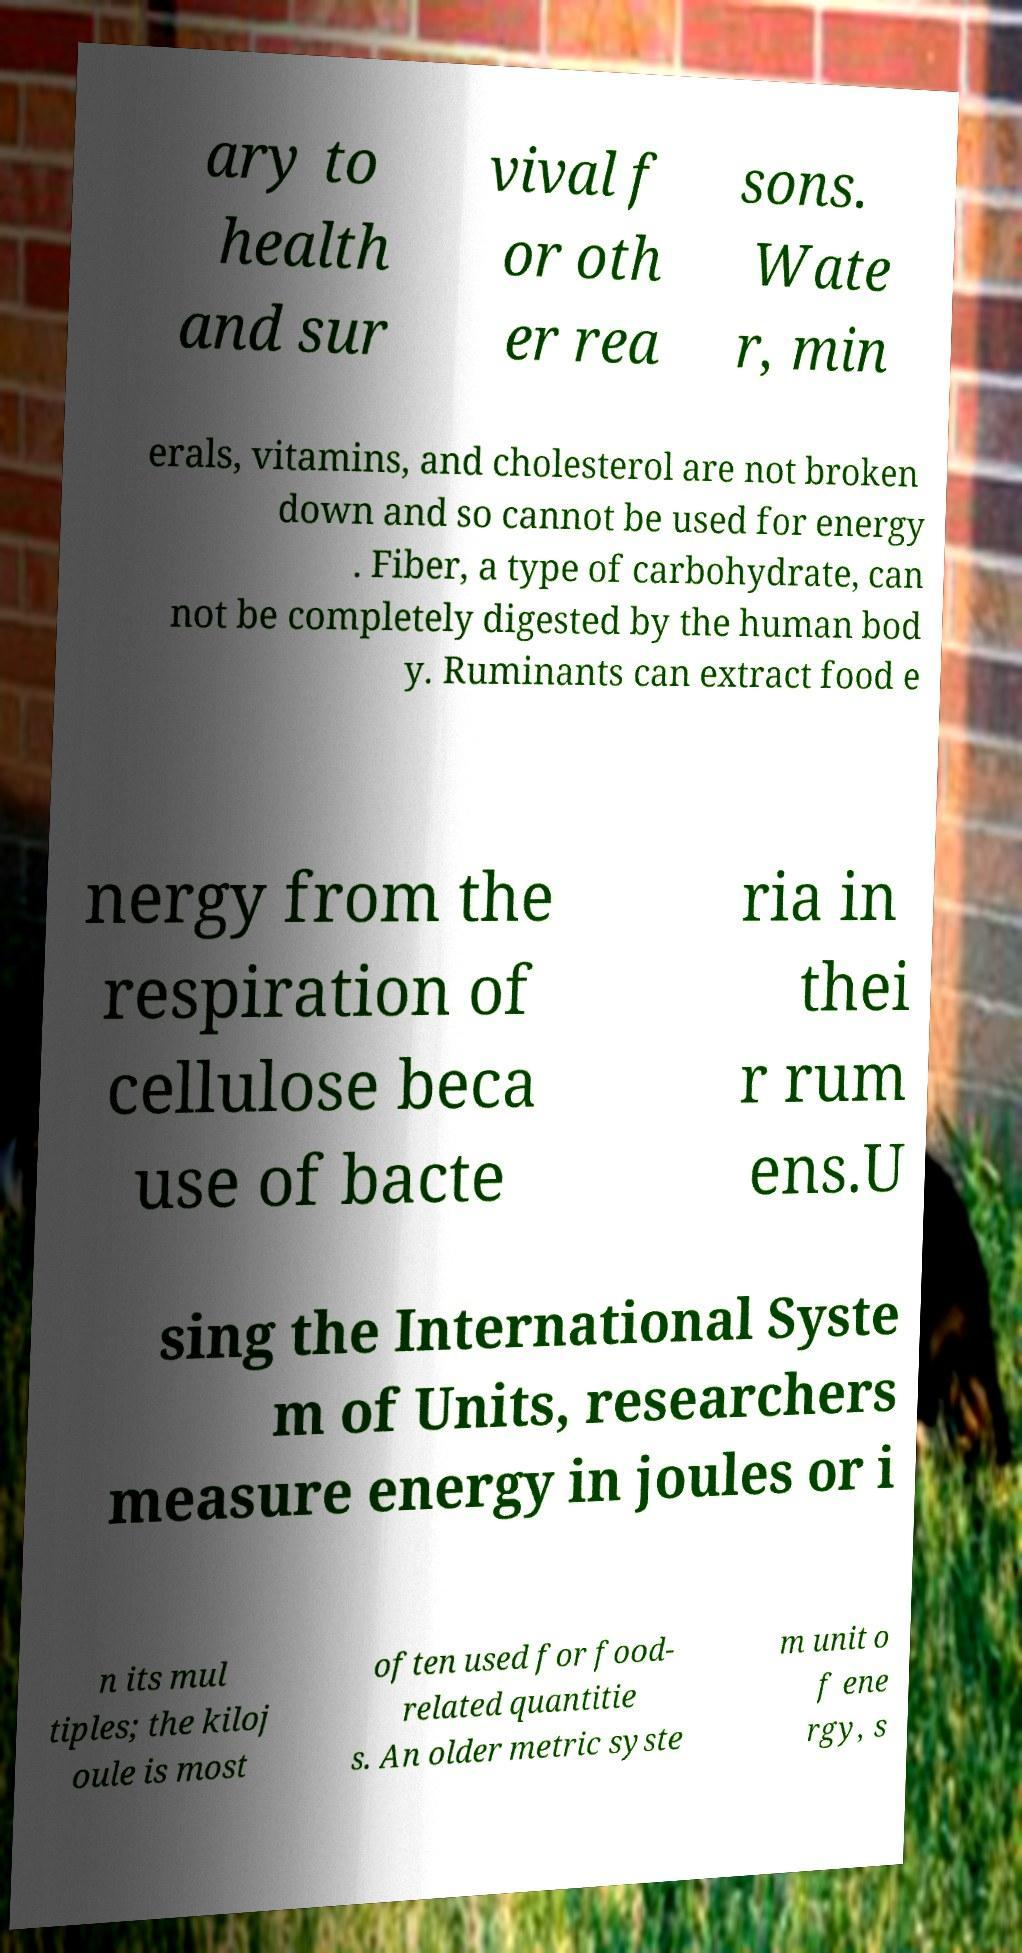Could you extract and type out the text from this image? ary to health and sur vival f or oth er rea sons. Wate r, min erals, vitamins, and cholesterol are not broken down and so cannot be used for energy . Fiber, a type of carbohydrate, can not be completely digested by the human bod y. Ruminants can extract food e nergy from the respiration of cellulose beca use of bacte ria in thei r rum ens.U sing the International Syste m of Units, researchers measure energy in joules or i n its mul tiples; the kiloj oule is most often used for food- related quantitie s. An older metric syste m unit o f ene rgy, s 